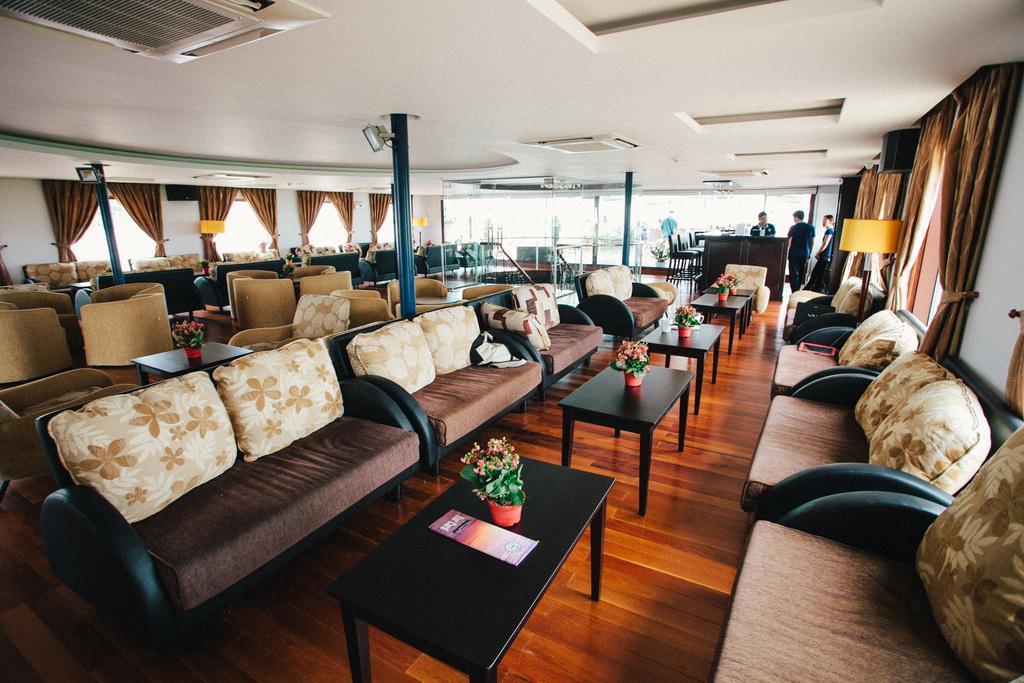How would you summarize this image in a sentence or two? In this image I can see number of cushions and couches. Here I can see tables and flowers on every table. In the background I can see few people, lamps, lights, speaker and curtains. 